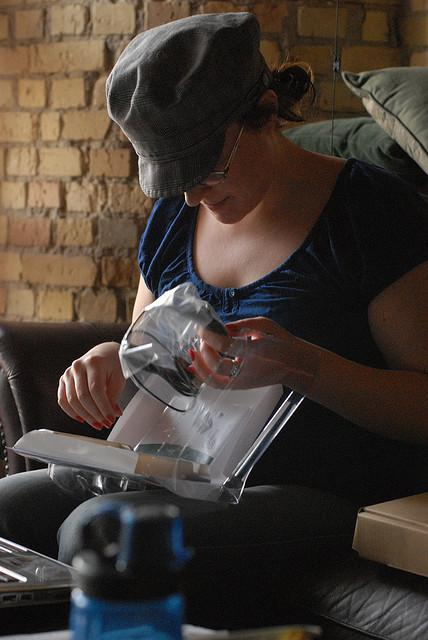What's the lady wearing on her head? hat 